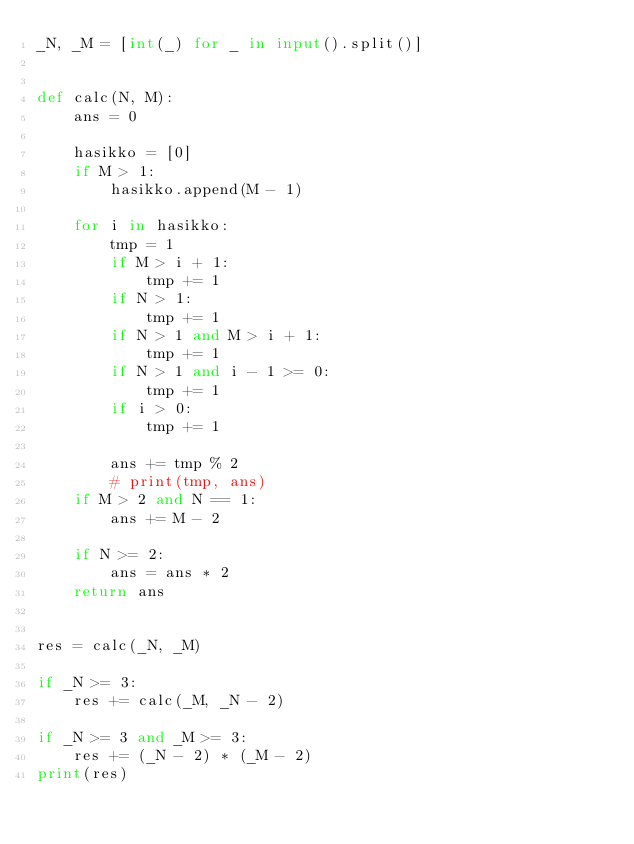Convert code to text. <code><loc_0><loc_0><loc_500><loc_500><_Python_>_N, _M = [int(_) for _ in input().split()]


def calc(N, M):
    ans = 0

    hasikko = [0]
    if M > 1:
        hasikko.append(M - 1)

    for i in hasikko:
        tmp = 1
        if M > i + 1:
            tmp += 1
        if N > 1:
            tmp += 1
        if N > 1 and M > i + 1:
            tmp += 1
        if N > 1 and i - 1 >= 0:
            tmp += 1
        if i > 0:
            tmp += 1

        ans += tmp % 2
        # print(tmp, ans)
    if M > 2 and N == 1:
        ans += M - 2

    if N >= 2:
        ans = ans * 2
    return ans


res = calc(_N, _M)

if _N >= 3:
    res += calc(_M, _N - 2)

if _N >= 3 and _M >= 3:
    res += (_N - 2) * (_M - 2)
print(res)
</code> 